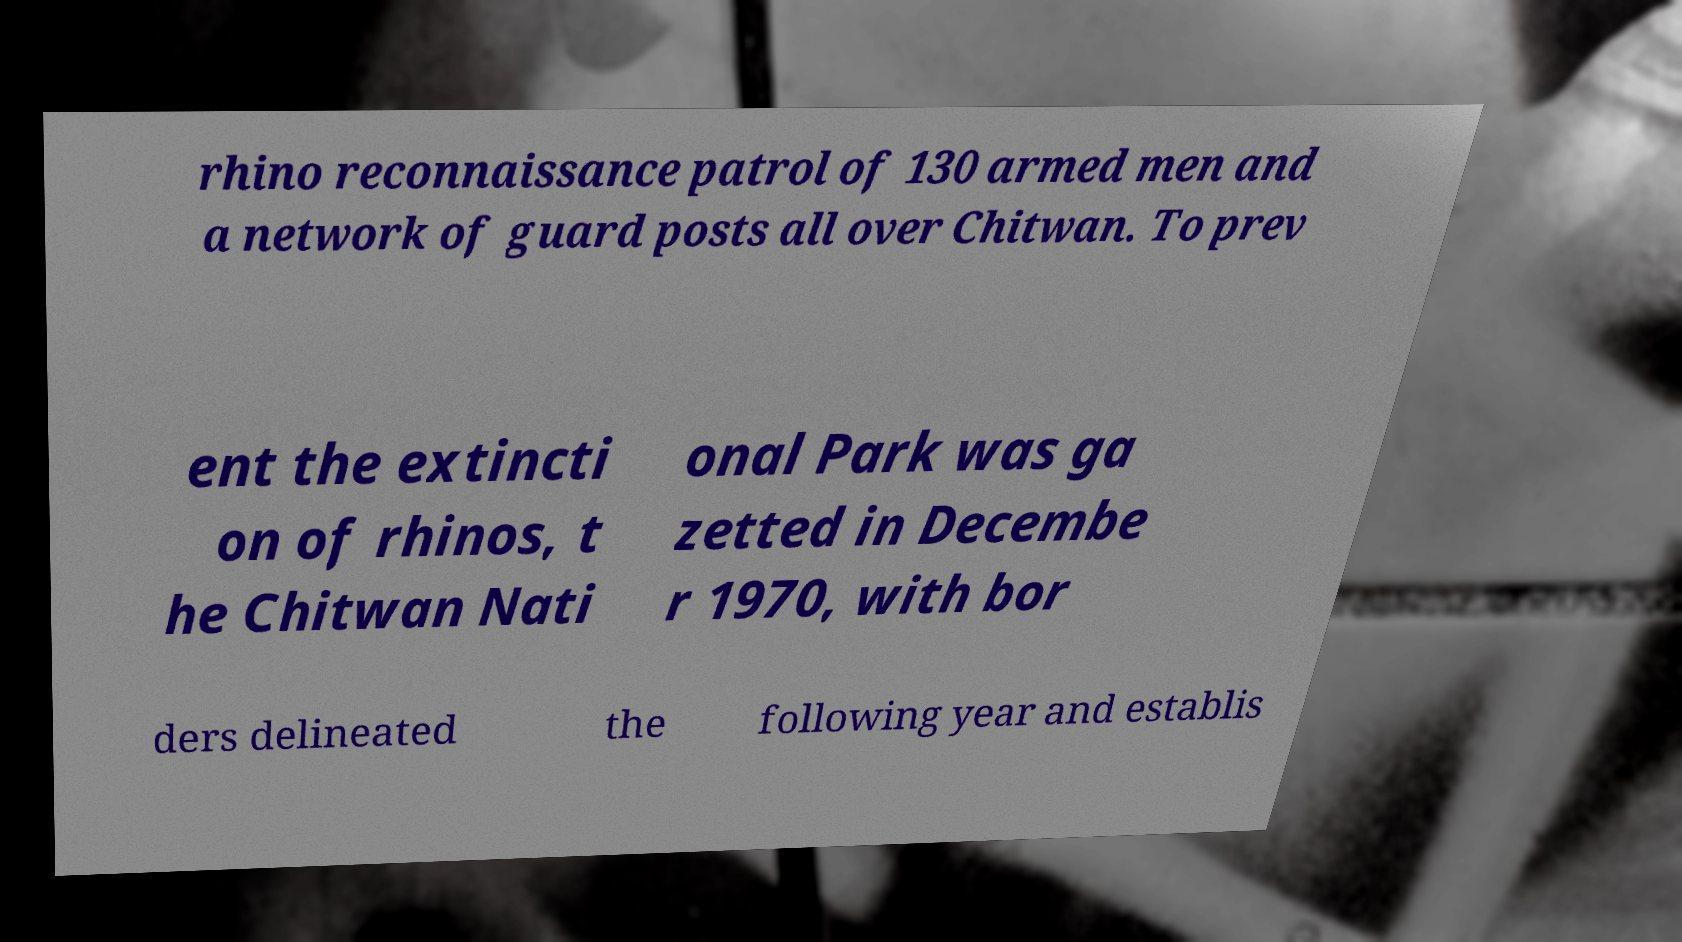What messages or text are displayed in this image? I need them in a readable, typed format. rhino reconnaissance patrol of 130 armed men and a network of guard posts all over Chitwan. To prev ent the extincti on of rhinos, t he Chitwan Nati onal Park was ga zetted in Decembe r 1970, with bor ders delineated the following year and establis 